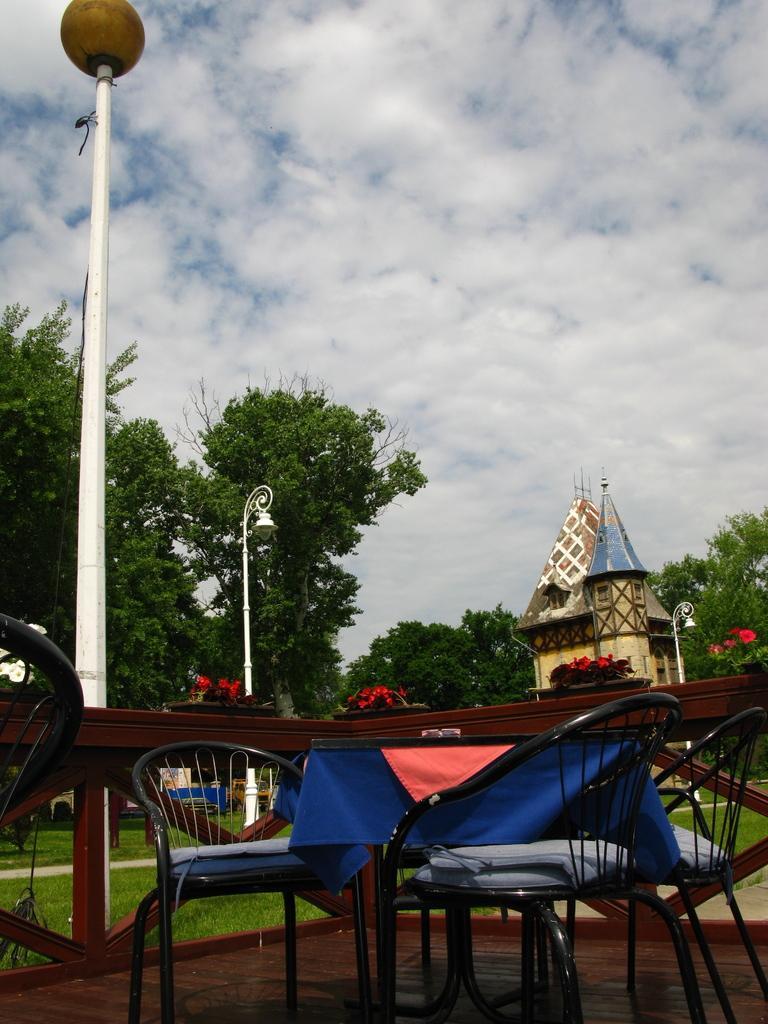Can you describe this image briefly? In the foreground of the picture I can see the table and chairs on the wooden floor. I can see the table covered with a multi color cloth. I can see the wooden fence. I can see two decorative light poles on the left side. In the background, I can see a house construction and trees. There are clouds in the sky. 